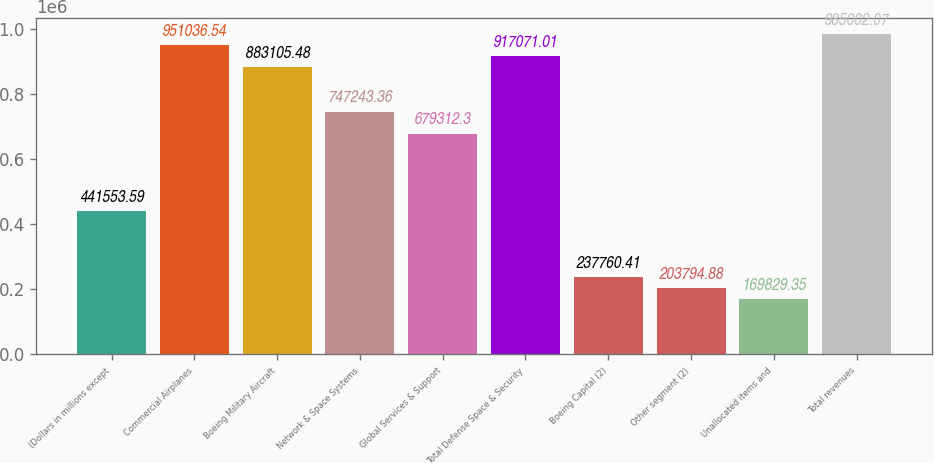Convert chart to OTSL. <chart><loc_0><loc_0><loc_500><loc_500><bar_chart><fcel>(Dollars in millions except<fcel>Commercial Airplanes<fcel>Boeing Military Aircraft<fcel>Network & Space Systems<fcel>Global Services & Support<fcel>Total Defense Space & Security<fcel>Boeing Capital (2)<fcel>Other segment (2)<fcel>Unallocated items and<fcel>Total revenues<nl><fcel>441554<fcel>951037<fcel>883105<fcel>747243<fcel>679312<fcel>917071<fcel>237760<fcel>203795<fcel>169829<fcel>985002<nl></chart> 